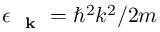Convert formula to latex. <formula><loc_0><loc_0><loc_500><loc_500>\epsilon _ { k } = \hbar { ^ } { 2 } k ^ { 2 } / 2 m</formula> 